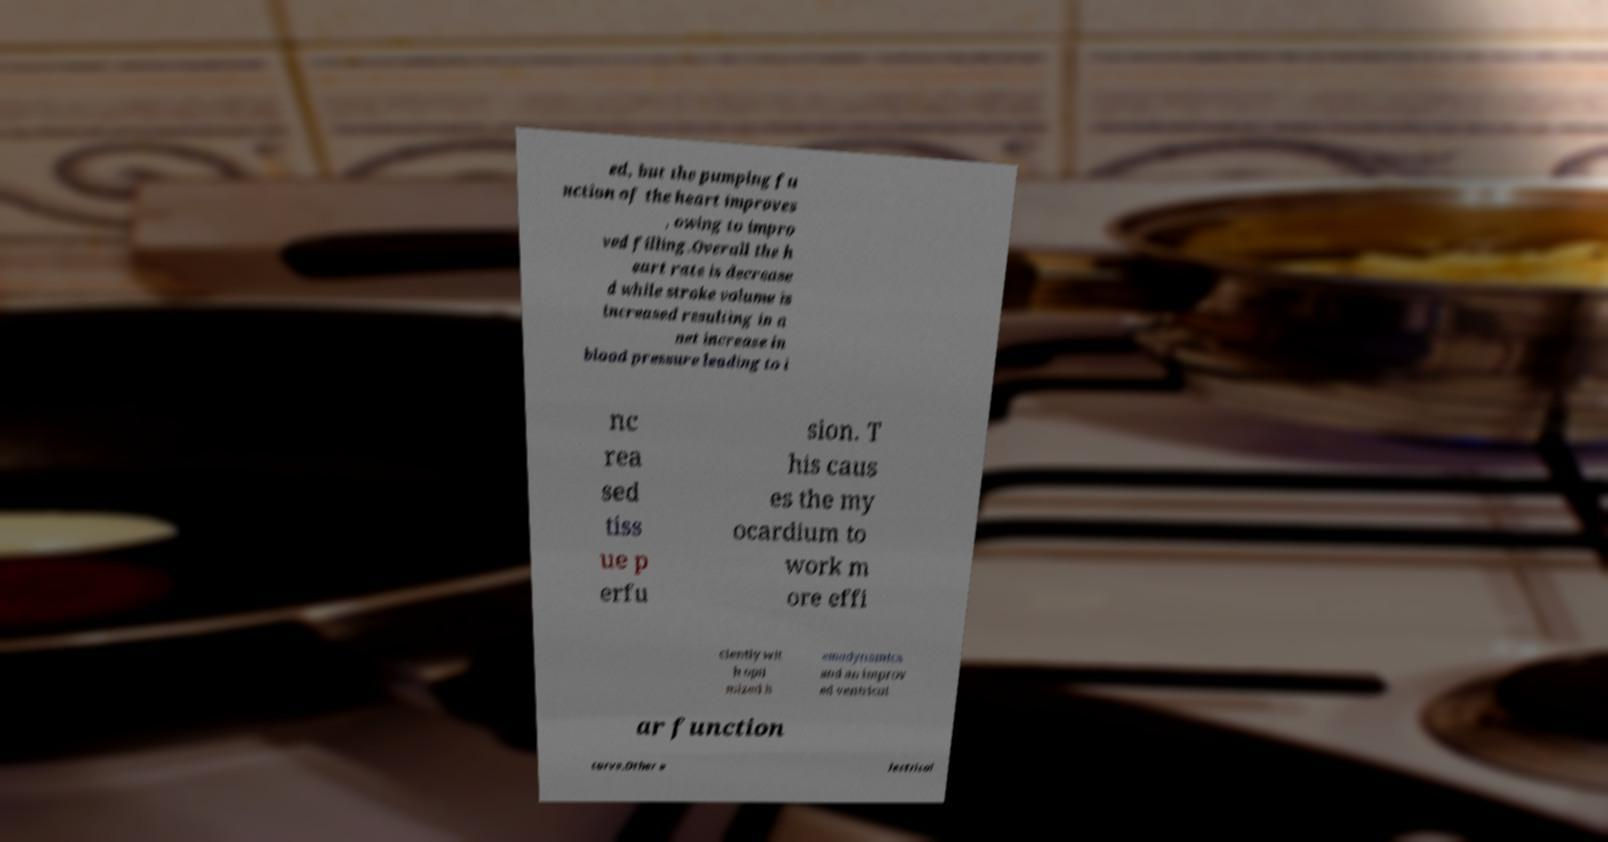For documentation purposes, I need the text within this image transcribed. Could you provide that? ed, but the pumping fu nction of the heart improves , owing to impro ved filling.Overall the h eart rate is decrease d while stroke volume is increased resulting in a net increase in blood pressure leading to i nc rea sed tiss ue p erfu sion. T his caus es the my ocardium to work m ore effi ciently wit h opti mized h emodynamics and an improv ed ventricul ar function curve.Other e lectrical 